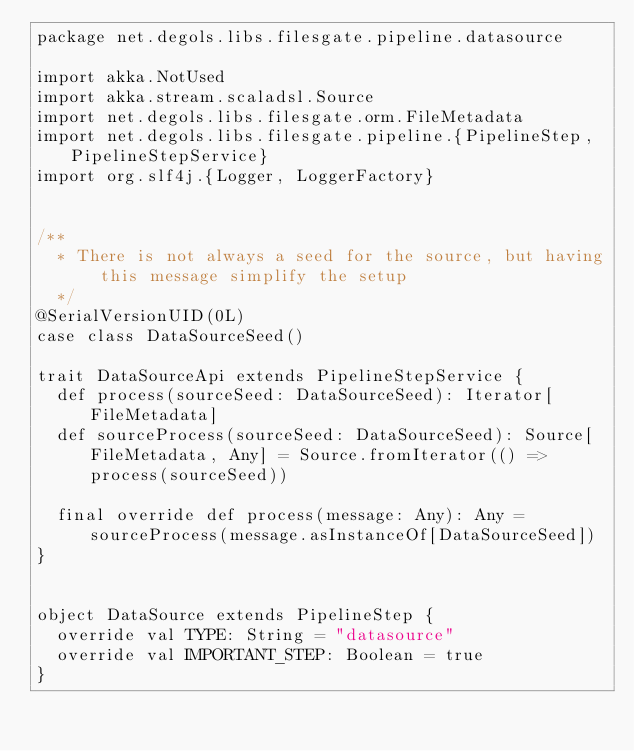<code> <loc_0><loc_0><loc_500><loc_500><_Scala_>package net.degols.libs.filesgate.pipeline.datasource

import akka.NotUsed
import akka.stream.scaladsl.Source
import net.degols.libs.filesgate.orm.FileMetadata
import net.degols.libs.filesgate.pipeline.{PipelineStep, PipelineStepService}
import org.slf4j.{Logger, LoggerFactory}


/**
  * There is not always a seed for the source, but having this message simplify the setup
  */
@SerialVersionUID(0L)
case class DataSourceSeed()

trait DataSourceApi extends PipelineStepService {
  def process(sourceSeed: DataSourceSeed): Iterator[FileMetadata]
  def sourceProcess(sourceSeed: DataSourceSeed): Source[FileMetadata, Any] = Source.fromIterator(() => process(sourceSeed))

  final override def process(message: Any): Any = sourceProcess(message.asInstanceOf[DataSourceSeed])
}


object DataSource extends PipelineStep {
  override val TYPE: String = "datasource"
  override val IMPORTANT_STEP: Boolean = true
}</code> 